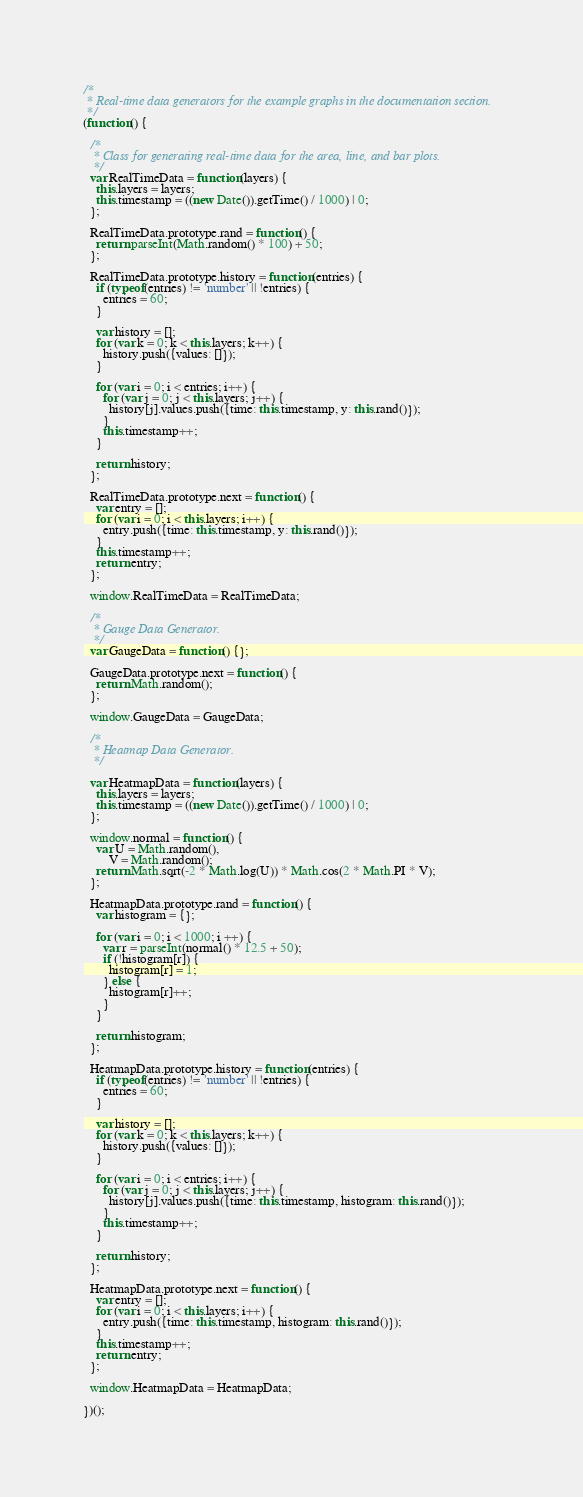Convert code to text. <code><loc_0><loc_0><loc_500><loc_500><_JavaScript_>/*
 * Real-time data generators for the example graphs in the documentation section.
 */
(function() {

  /*
   * Class for generating real-time data for the area, line, and bar plots.
   */
  var RealTimeData = function(layers) {
    this.layers = layers;
    this.timestamp = ((new Date()).getTime() / 1000) | 0;
  };

  RealTimeData.prototype.rand = function() {
    return parseInt(Math.random() * 100) + 50;
  };

  RealTimeData.prototype.history = function(entries) {
    if (typeof(entries) != 'number' || !entries) {
      entries = 60;
    }

    var history = [];
    for (var k = 0; k < this.layers; k++) {
      history.push({values: []});
    }

    for (var i = 0; i < entries; i++) {
      for (var j = 0; j < this.layers; j++) {
        history[j].values.push({time: this.timestamp, y: this.rand()});
      }
      this.timestamp++;
    }

    return history;
  };

  RealTimeData.prototype.next = function() {
    var entry = [];
    for (var i = 0; i < this.layers; i++) {
      entry.push({time: this.timestamp, y: this.rand()});
    }
    this.timestamp++;
    return entry;
  };

  window.RealTimeData = RealTimeData;

  /*
   * Gauge Data Generator.
   */
  var GaugeData = function() {};

  GaugeData.prototype.next = function() {
    return Math.random();
  };

  window.GaugeData = GaugeData;

  /*
   * Heatmap Data Generator.
   */

  var HeatmapData = function(layers) {
    this.layers = layers;
    this.timestamp = ((new Date()).getTime() / 1000) | 0;
  };

  window.normal = function() {
    var U = Math.random(),
        V = Math.random();
    return Math.sqrt(-2 * Math.log(U)) * Math.cos(2 * Math.PI * V);
  };

  HeatmapData.prototype.rand = function() {
    var histogram = {};

    for (var i = 0; i < 1000; i ++) {
      var r = parseInt(normal() * 12.5 + 50);
      if (!histogram[r]) {
        histogram[r] = 1;
      } else {
        histogram[r]++;
      }
    }

    return histogram;
  };

  HeatmapData.prototype.history = function(entries) {
    if (typeof(entries) != 'number' || !entries) {
      entries = 60;
    }

    var history = [];
    for (var k = 0; k < this.layers; k++) {
      history.push({values: []});
    }

    for (var i = 0; i < entries; i++) {
      for (var j = 0; j < this.layers; j++) {
        history[j].values.push({time: this.timestamp, histogram: this.rand()});
      }
      this.timestamp++;
    }

    return history;
  };

  HeatmapData.prototype.next = function() {
    var entry = [];
    for (var i = 0; i < this.layers; i++) {
      entry.push({time: this.timestamp, histogram: this.rand()});
    }
    this.timestamp++;
    return entry;
  };

  window.HeatmapData = HeatmapData;

})();
</code> 